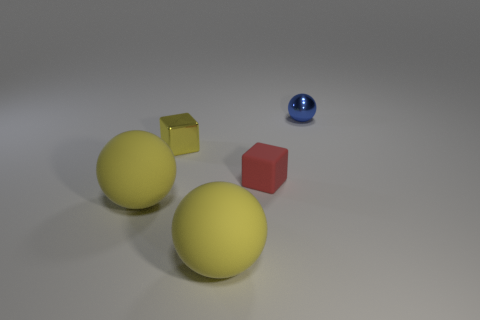Are there more metallic blocks in front of the tiny ball than tiny yellow cubes in front of the yellow cube?
Your response must be concise. Yes. What is the material of the yellow object that is in front of the large ball left of the small shiny object in front of the blue thing?
Make the answer very short. Rubber. There is a tiny shiny object to the left of the red object; is it the same shape as the red thing in front of the small metal cube?
Your response must be concise. Yes. Are there any red matte objects of the same size as the blue metallic ball?
Your answer should be very brief. Yes. What number of blue objects are either metal objects or metal cubes?
Your answer should be compact. 1. What number of large matte balls have the same color as the small metal block?
Keep it short and to the point. 2. How many cubes are either small blue metal objects or tiny yellow things?
Provide a succinct answer. 1. There is a ball that is behind the red rubber block; what is its color?
Give a very brief answer. Blue. The red thing that is the same size as the yellow block is what shape?
Your response must be concise. Cube. What number of shiny balls are to the left of the small blue metallic sphere?
Offer a terse response. 0. 